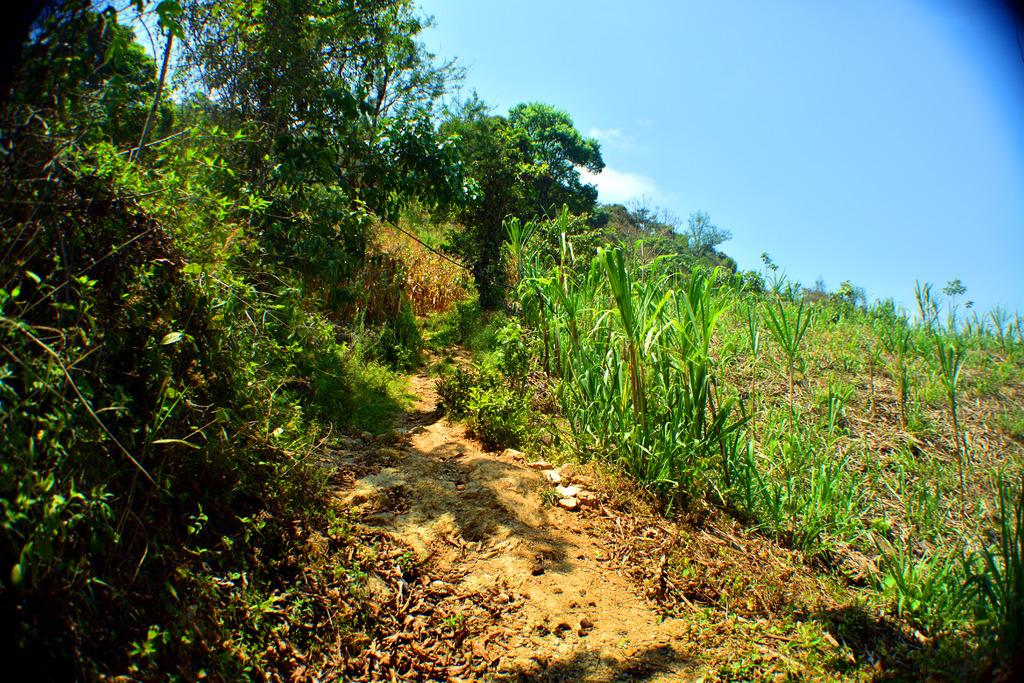What type of vegetation or plants can be seen in the image? There is greenery visible in the image, which suggests the presence of plants or vegetation. Can you see a beetle crawling on the straw in the image? There is no straw or beetle present in the image; only greenery is visible. 